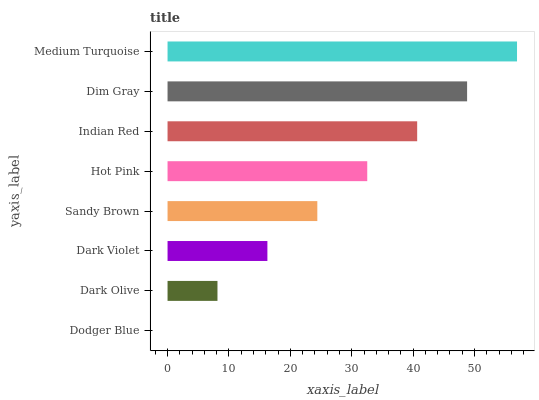Is Dodger Blue the minimum?
Answer yes or no. Yes. Is Medium Turquoise the maximum?
Answer yes or no. Yes. Is Dark Olive the minimum?
Answer yes or no. No. Is Dark Olive the maximum?
Answer yes or no. No. Is Dark Olive greater than Dodger Blue?
Answer yes or no. Yes. Is Dodger Blue less than Dark Olive?
Answer yes or no. Yes. Is Dodger Blue greater than Dark Olive?
Answer yes or no. No. Is Dark Olive less than Dodger Blue?
Answer yes or no. No. Is Hot Pink the high median?
Answer yes or no. Yes. Is Sandy Brown the low median?
Answer yes or no. Yes. Is Dodger Blue the high median?
Answer yes or no. No. Is Dodger Blue the low median?
Answer yes or no. No. 